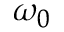<formula> <loc_0><loc_0><loc_500><loc_500>\omega _ { 0 }</formula> 